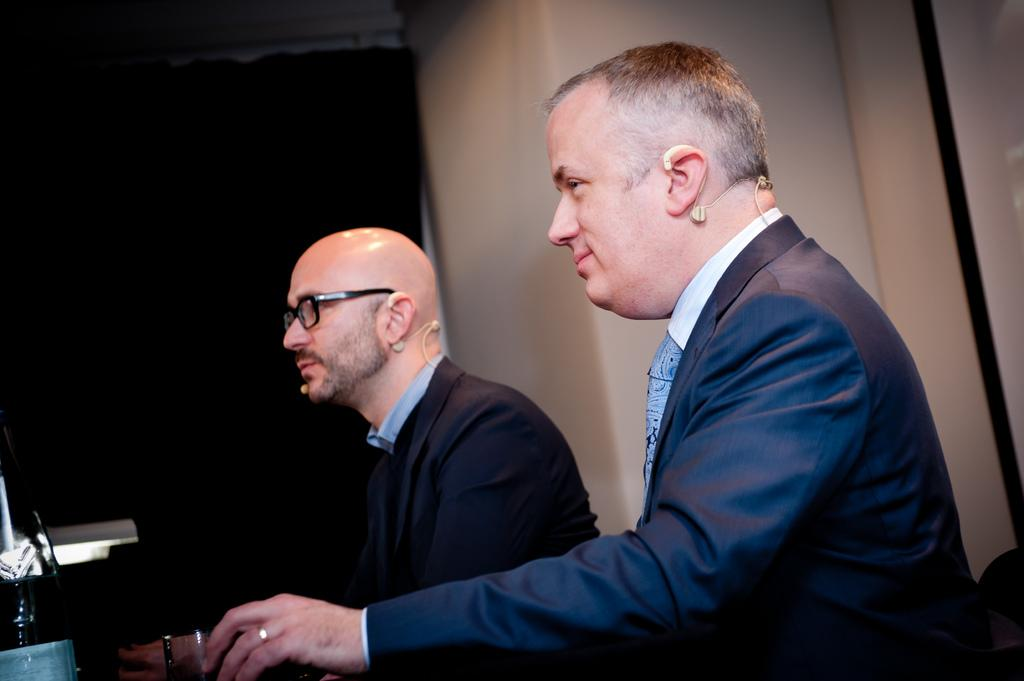How many people are in the image? There are two persons in the image. What are the persons wearing on their heads? The persons are wearing headset mics. What can be seen between the persons in the image? There is an object in front of the persons. What is visible in the background of the image? There is a wall in the background of the image. Can you see a window in the image? There is no window visible in the image; only a wall is present in the background. 